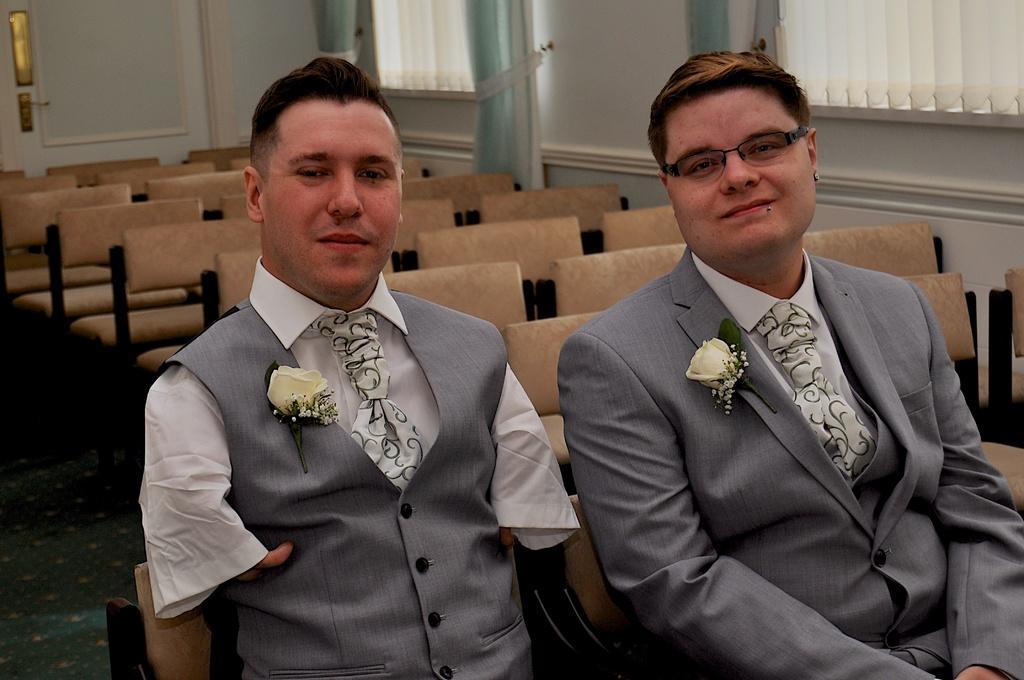Can you describe this image briefly? In this picture I can see few people sitting on the chairs and I can see few empty chairs in the back and I can see blinds to the windows. 